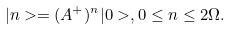<formula> <loc_0><loc_0><loc_500><loc_500>| n > = ( A ^ { + } ) ^ { n } | 0 > , 0 \leq n \leq 2 \Omega .</formula> 